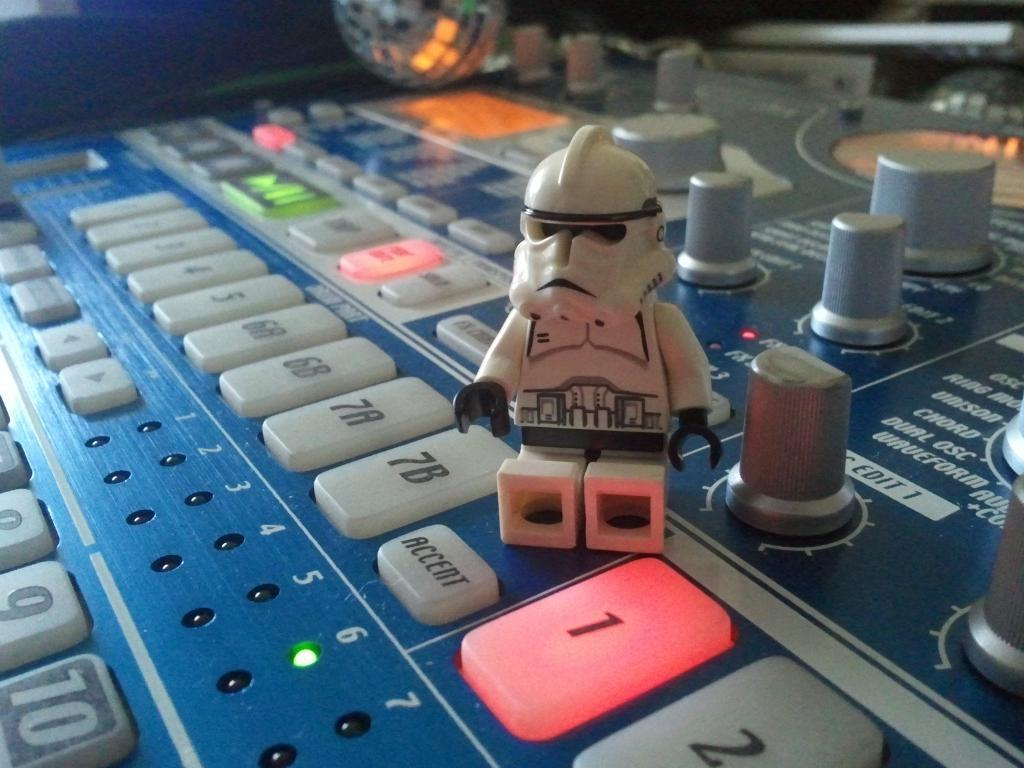<image>
Render a clear and concise summary of the photo. A LEGO Stormtrooper sits next to an illuminated number 1 button. 